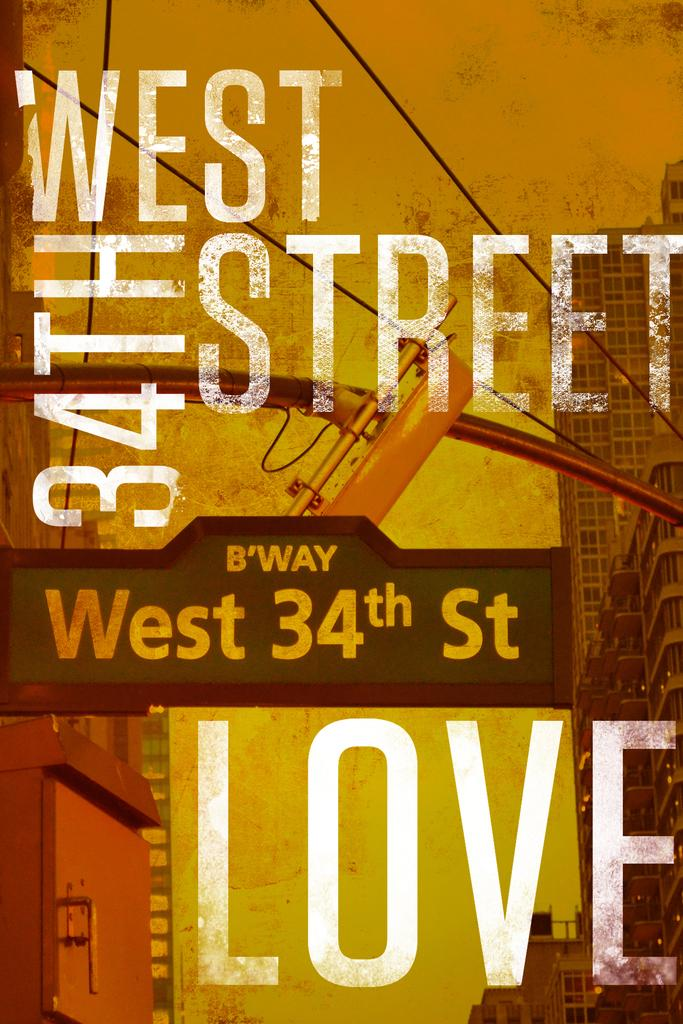<image>
Relay a brief, clear account of the picture shown. A poster of West 34th Street Love is displayed. 